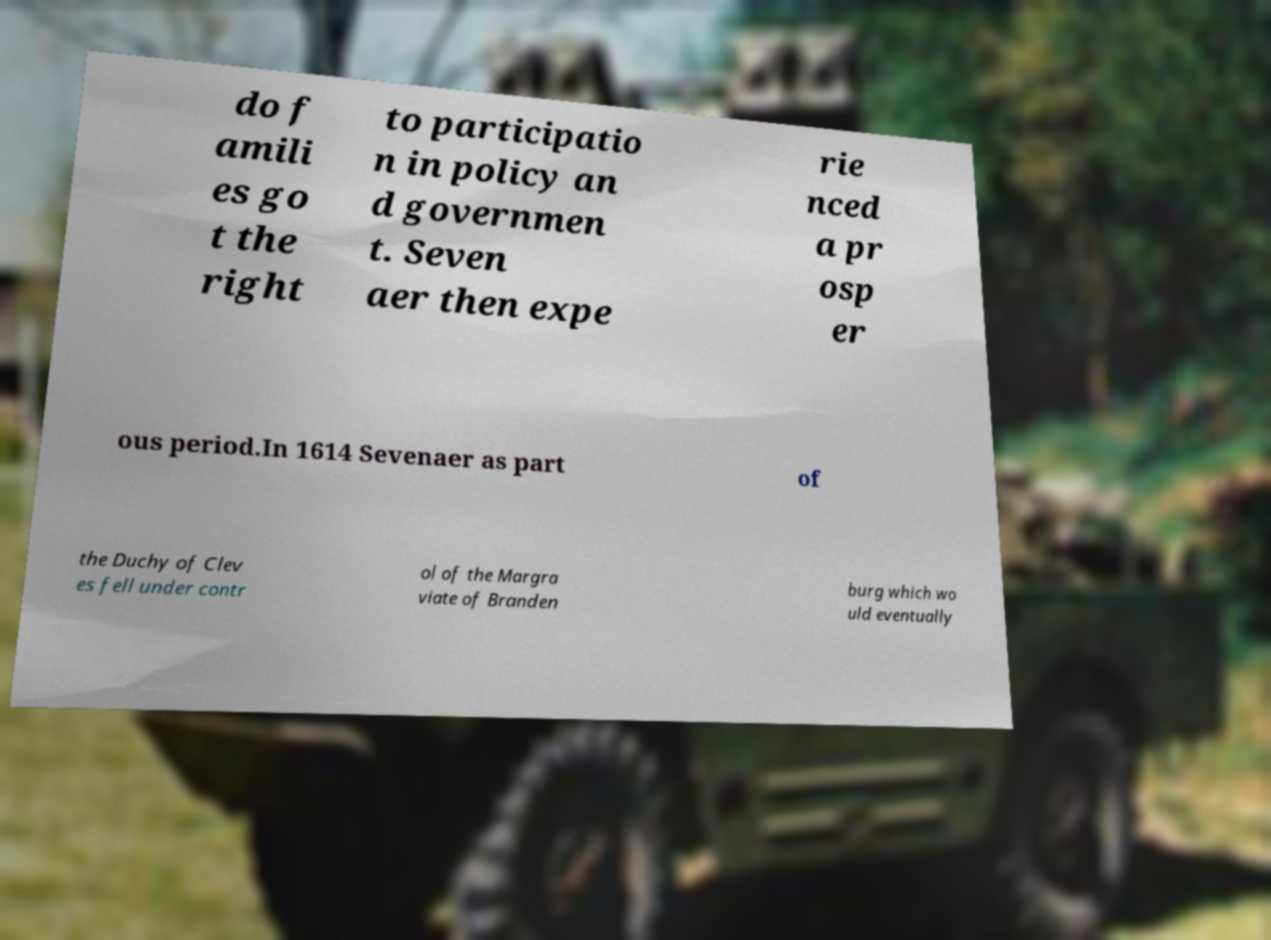Could you extract and type out the text from this image? do f amili es go t the right to participatio n in policy an d governmen t. Seven aer then expe rie nced a pr osp er ous period.In 1614 Sevenaer as part of the Duchy of Clev es fell under contr ol of the Margra viate of Branden burg which wo uld eventually 